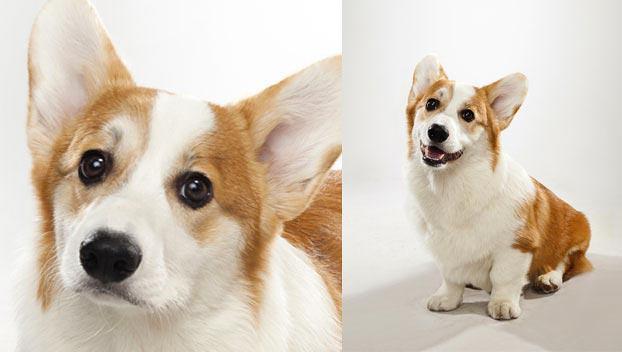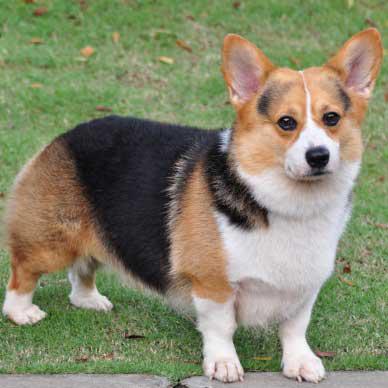The first image is the image on the left, the second image is the image on the right. Evaluate the accuracy of this statement regarding the images: "There are 3 dogs.". Is it true? Answer yes or no. Yes. 